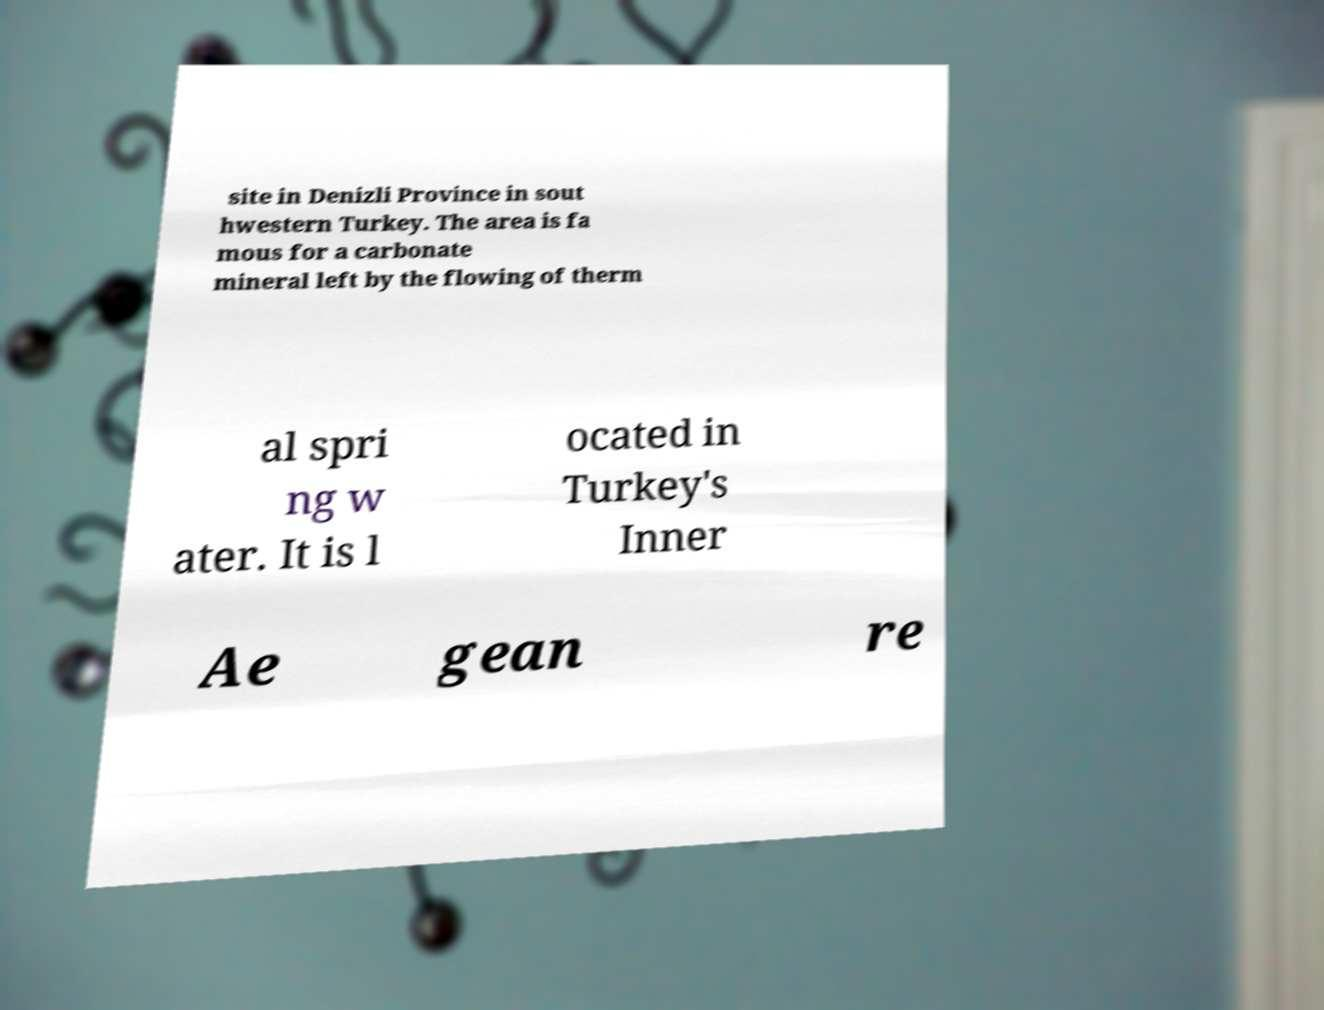Could you extract and type out the text from this image? site in Denizli Province in sout hwestern Turkey. The area is fa mous for a carbonate mineral left by the flowing of therm al spri ng w ater. It is l ocated in Turkey's Inner Ae gean re 